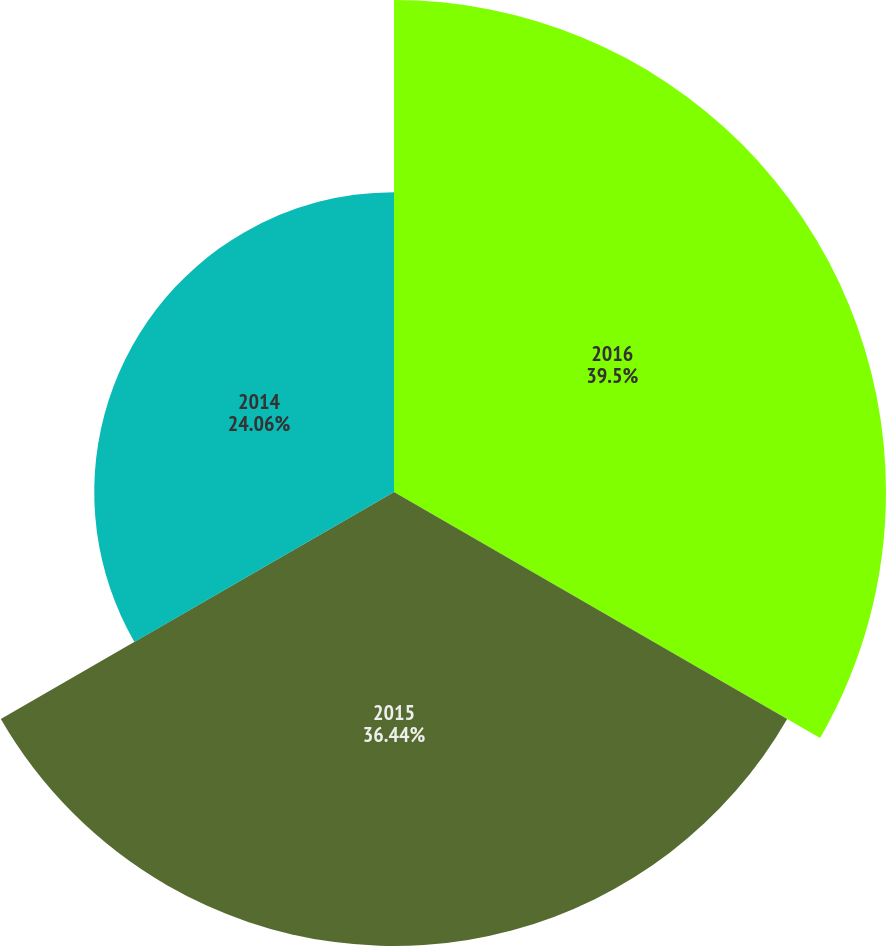Convert chart to OTSL. <chart><loc_0><loc_0><loc_500><loc_500><pie_chart><fcel>2016<fcel>2015<fcel>2014<nl><fcel>39.49%<fcel>36.44%<fcel>24.06%<nl></chart> 